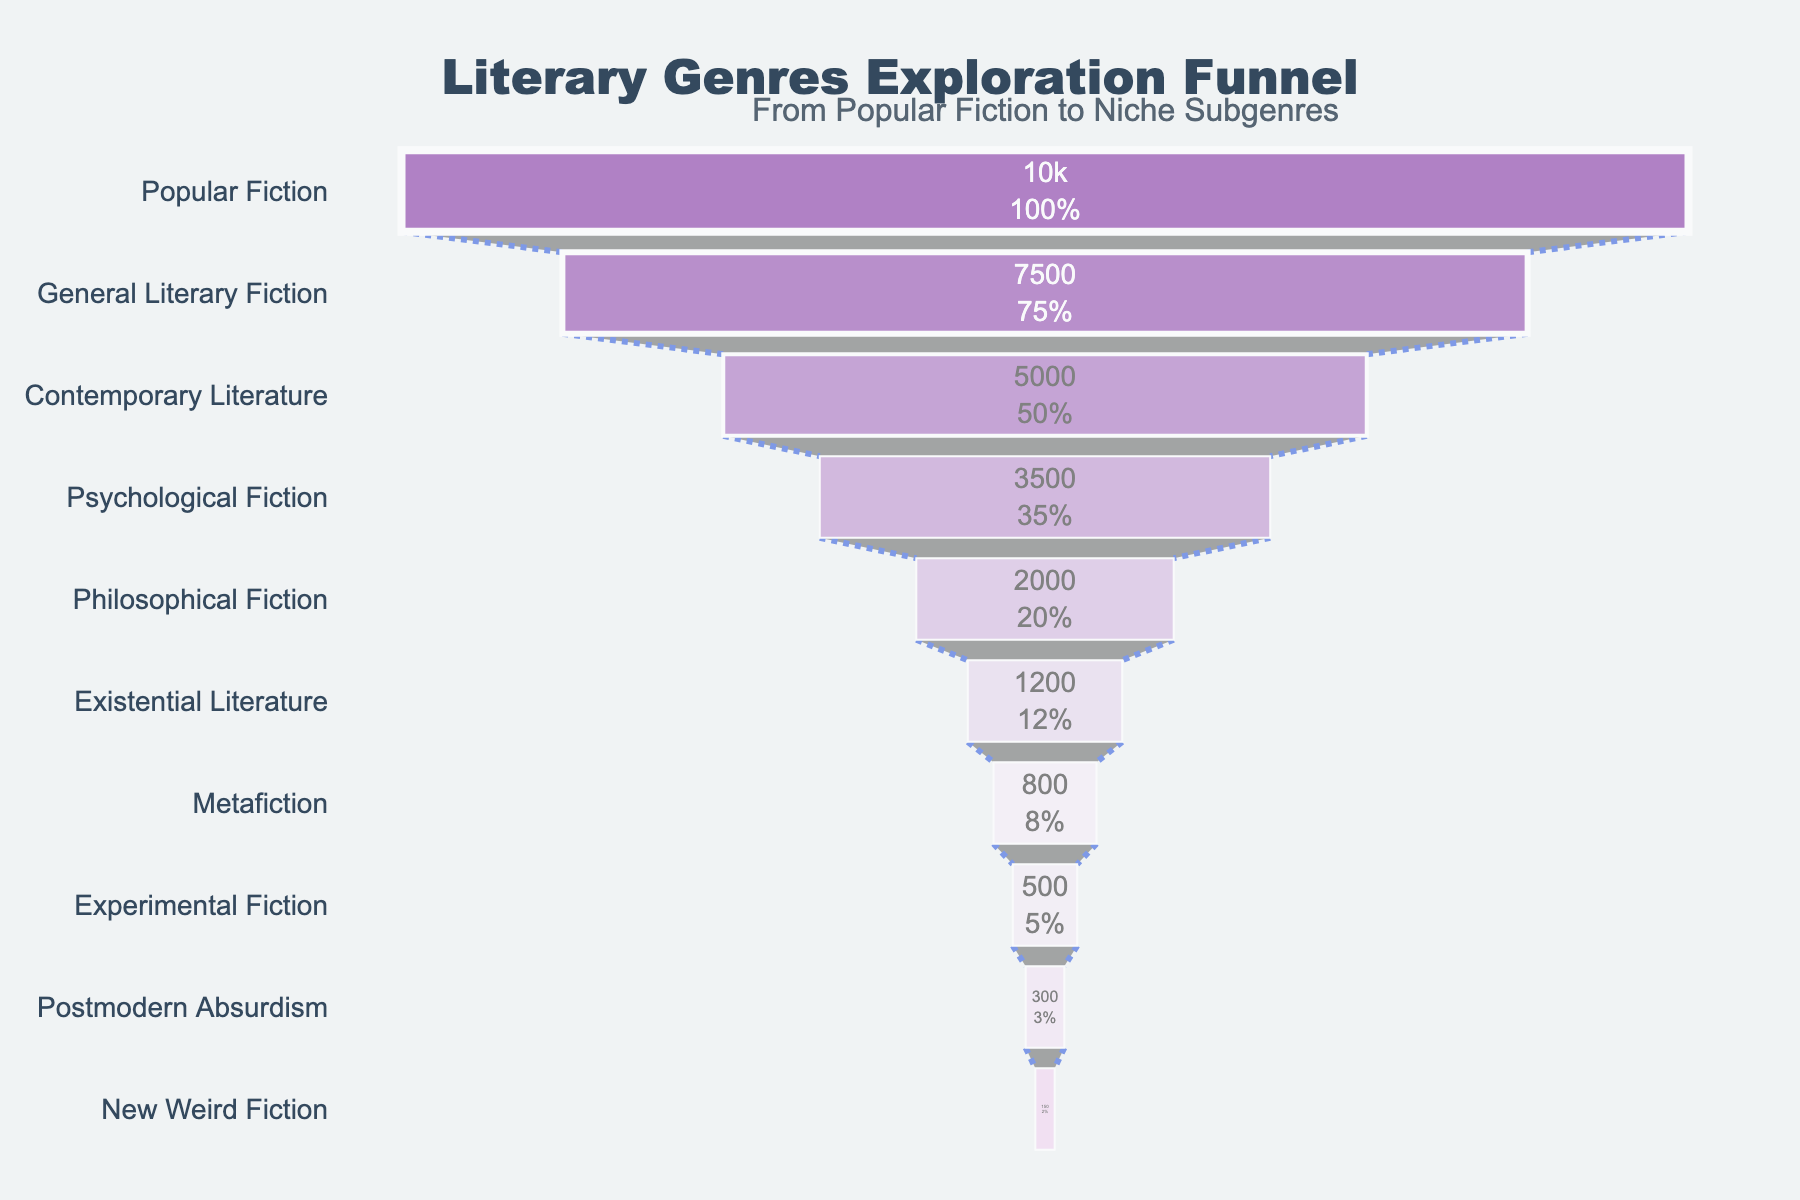What is the title of the funnel chart? The title is usually located at the top of the chart. In this case, it clearly states the subject of the figure.
Answer: Literary Genres Exploration Funnel How many stages are there in the funnel chart? By counting the different categories (stages) listed on the y-axis, we can find out the number of stages.
Answer: 10 What percentage of initial readers move from Popular Fiction to General Literary Fiction? The figure shows both the number of readers and the percentage of the initial readers at each stage. For General Literary Fiction, look at the percentage value next to the reader count.
Answer: 75% Which stage has the fewest readers and how many? The stage with the fewest readers is the one at the bottom of the funnel. The reader count and stage name are displayed inside each section.
Answer: New Weird Fiction, 150 What is the difference in the number of readers between Psychological Fiction and Contemporary Literature? Identify the reader counts for both stages and then calculate the difference by subtracting the lower value from the higher value.
Answer: 1500 Which stages have fewer than 1000 readers? Examine the reader counts for each stage and note those with a count below 1000.
Answer: Metafiction, Experimental Fiction, Postmodern Absurdism, New Weird Fiction How does the decline in readers from Popular Fiction to General Literary Fiction compare to the decline from General Literary Fiction to Contemporary Literature? Calculate the differences in reader counts between these stages and compare the values.
Answer: 2500 vs. 2500 (Equal decline) Which stage, Psychological Fiction or Philosophical Fiction, has more readers, and by how much? Compare the reader counts for these two stages and calculate the difference.
Answer: Psychological Fiction by 1500 readers What is the total number of readers in all stages combined? Sum up the reader counts from all stages to find the total.
Answer: 10000 + 7500 + 5000 + 3500 + 2000 + 1200 + 800 + 500 + 300 + 150 = 34250 What annotation is included in this chart? Look for any text outside the main sections of the funnel chart that provides additional context or information.
Answer: From Popular Fiction to Niche Subgenres 